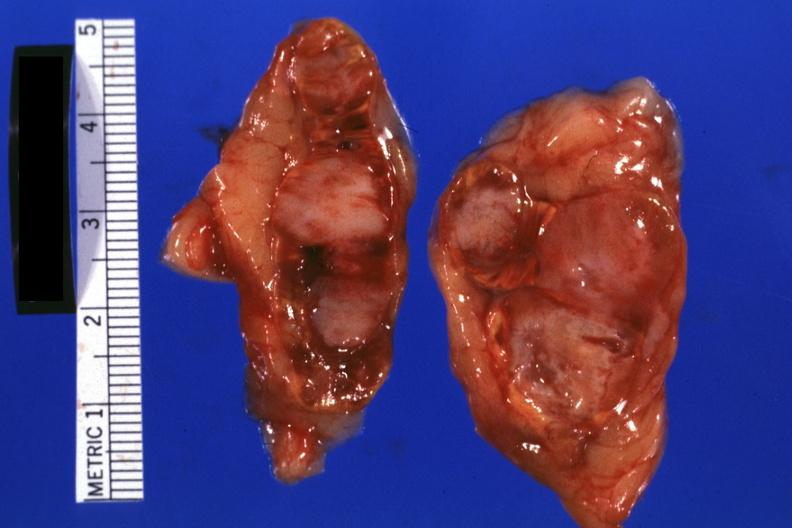what does this image show?
Answer the question using a single word or phrase. Excellent example lul scar adenocarcinoma 